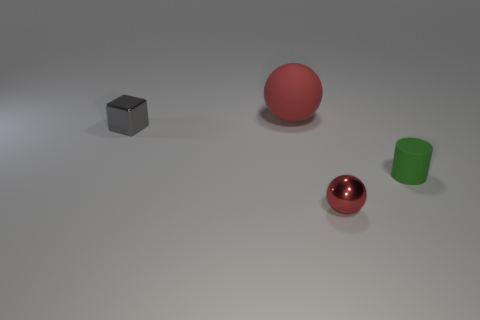What size is the other matte thing that is the same shape as the small red thing?
Provide a short and direct response. Large. What number of objects are right of the tiny gray shiny object and in front of the red rubber thing?
Give a very brief answer. 2. There is a large red matte object; is it the same shape as the matte thing that is in front of the block?
Provide a short and direct response. No. Are there more spheres left of the tiny green cylinder than big red rubber things?
Provide a succinct answer. Yes. Is the number of things that are in front of the red matte sphere less than the number of green cylinders?
Your answer should be very brief. No. How many cubes have the same color as the big rubber object?
Make the answer very short. 0. What is the material of the thing that is both behind the small red object and in front of the metallic cube?
Your answer should be very brief. Rubber. Do the object that is to the left of the red rubber thing and the ball behind the small metal cube have the same color?
Offer a very short reply. No. How many purple things are metal spheres or metallic things?
Give a very brief answer. 0. Is the number of red metal balls that are behind the red matte ball less than the number of red balls that are in front of the cylinder?
Offer a terse response. Yes. 